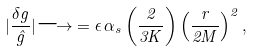Convert formula to latex. <formula><loc_0><loc_0><loc_500><loc_500>| \frac { \delta g } { \hat { g } } | { \longrightarrow } = \epsilon \, \alpha _ { s } \left ( \frac { 2 } { 3 K } \right ) \left ( \frac { r } { 2 M } \right ) ^ { 2 } ,</formula> 